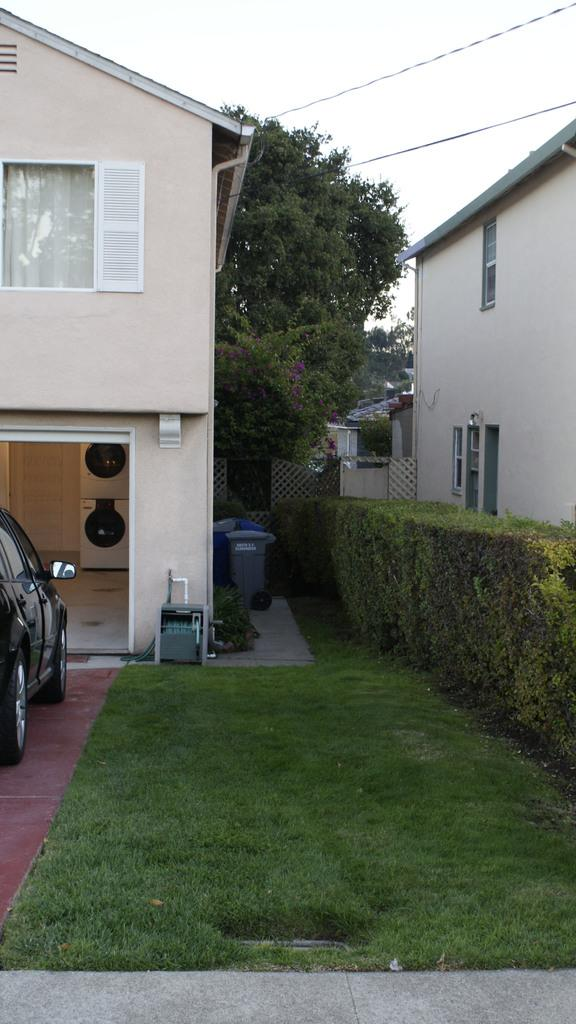What type of structures are visible in the image? There are houses in the image. What type of vegetation is at the bottom of the image? There is green grass at the bottom of the image. What can be seen on the left side of the image? There is a car on the left side of the image. What is located in the middle of the image? There are trees and dustbins in the middle of the image. What is visible at the top of the image? The sky is visible at the top of the image. What type of bells can be heard ringing in the image? There are no bells present in the image, and therefore no sounds can be heard. What type of drink is being consumed by the trees in the image? There are no trees consuming any drinks in the image. 